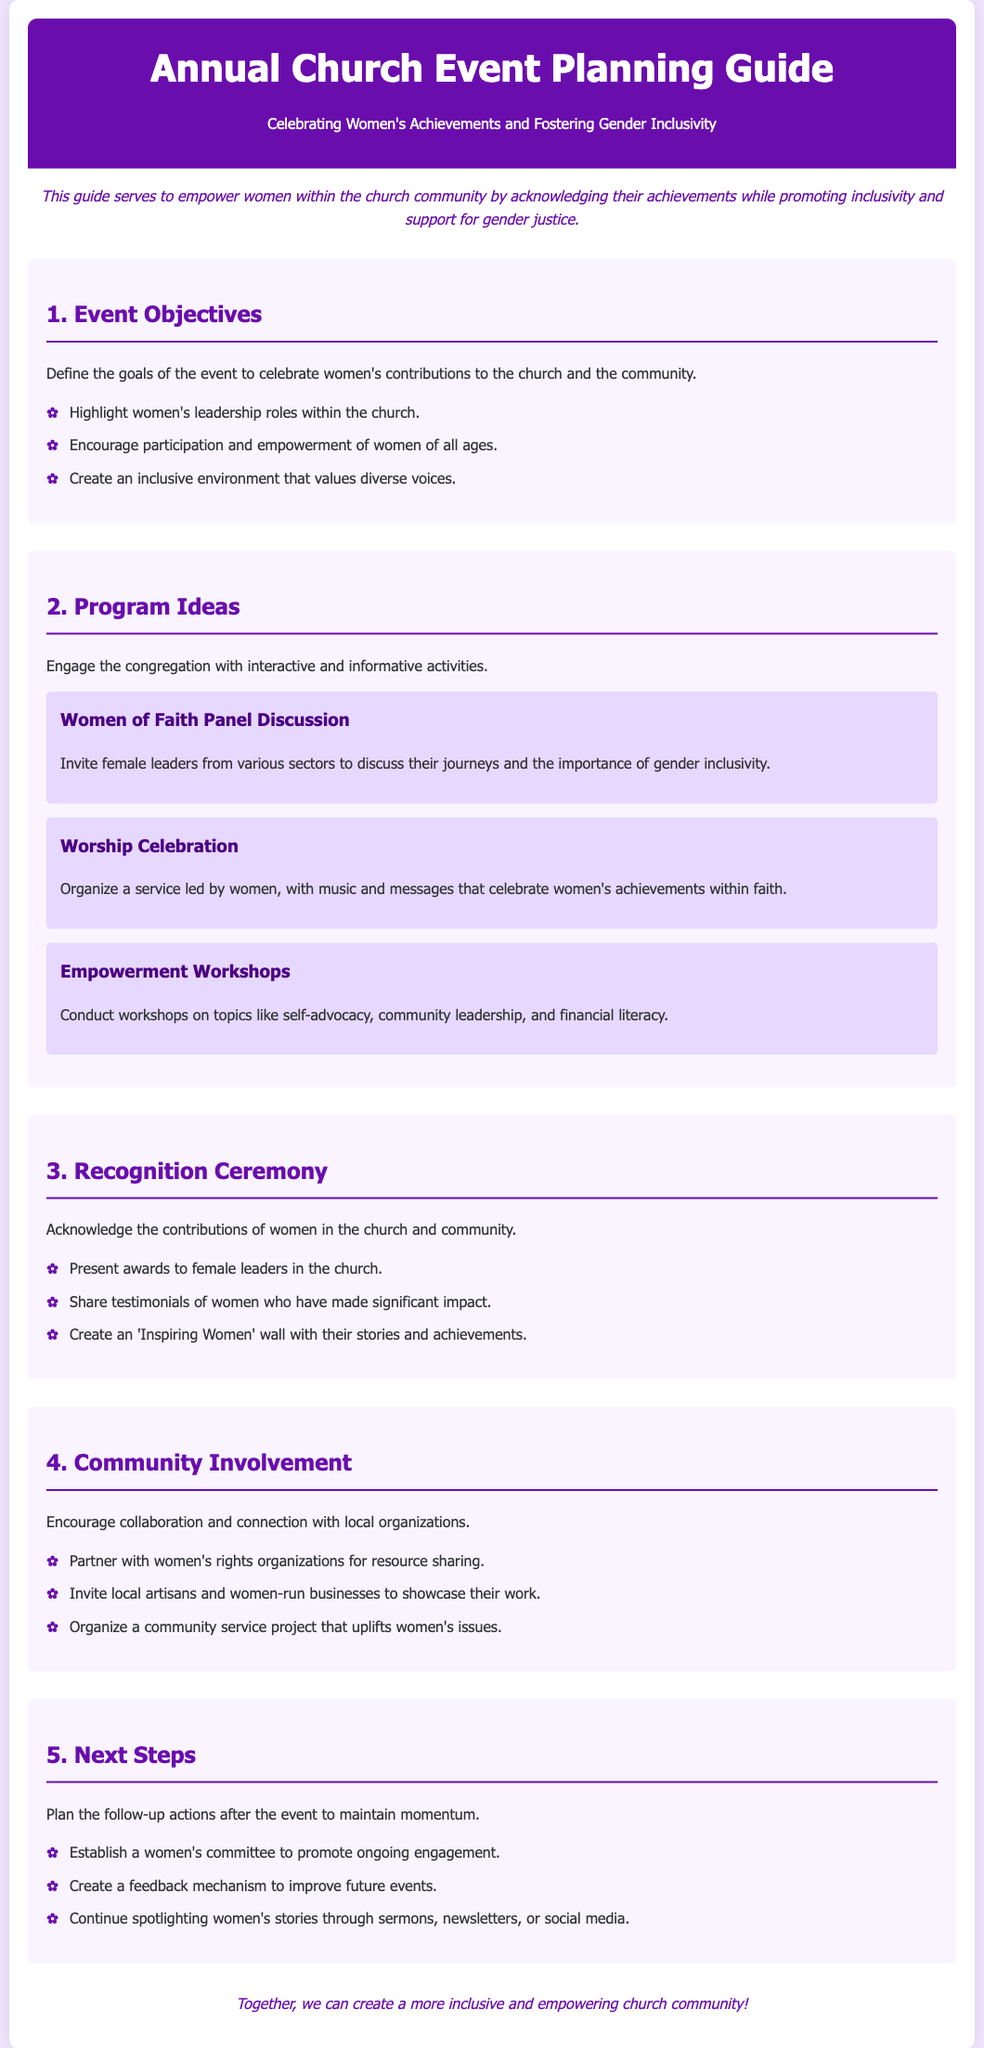What is the main focus of the guide? The guide focuses on celebrating women's achievements while fostering gender inclusivity.
Answer: Celebrating women's achievements and fostering gender inclusivity How many program ideas are listed in the document? There are three specific program ideas mentioned in the document.
Answer: Three What is one of the objectives of the event? Highlighting women's leadership roles within the church is one of the objectives.
Answer: Highlight women's leadership roles within the church What type of event is mentioned as a program idea? The document mentions a Worship Celebration as one of the program ideas.
Answer: Worship Celebration What should be established after the event according to the next steps? A women's committee should be established to promote ongoing engagement after the event.
Answer: women's committee What is included in the Recognition Ceremony section? Presenting awards to female leaders in the church is included in the Recognition Ceremony section.
Answer: Present awards to female leaders in the church Which organization can be partnered with for resource sharing? Women's rights organizations can be partnered with for resource sharing.
Answer: women's rights organizations How is the introduction of the guide styled? The introduction of the guide is styled in italic font.
Answer: italic What does the footer encourage the congregation to do? The footer encourages creating a more inclusive and empowering church community.
Answer: create a more inclusive and empowering church community 